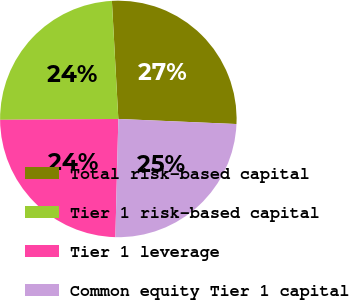<chart> <loc_0><loc_0><loc_500><loc_500><pie_chart><fcel>Total risk-based capital<fcel>Tier 1 risk-based capital<fcel>Tier 1 leverage<fcel>Common equity Tier 1 capital<nl><fcel>26.55%<fcel>24.25%<fcel>24.48%<fcel>24.71%<nl></chart> 